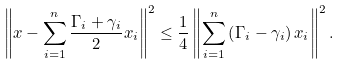Convert formula to latex. <formula><loc_0><loc_0><loc_500><loc_500>\left \| x - \sum _ { i = 1 } ^ { n } \frac { \Gamma _ { i } + \gamma _ { i } } { 2 } x _ { i } \right \| ^ { 2 } \leq \frac { 1 } { 4 } \left \| \sum _ { i = 1 } ^ { n } \left ( \Gamma _ { i } - \gamma _ { i } \right ) x _ { i } \right \| ^ { 2 } .</formula> 